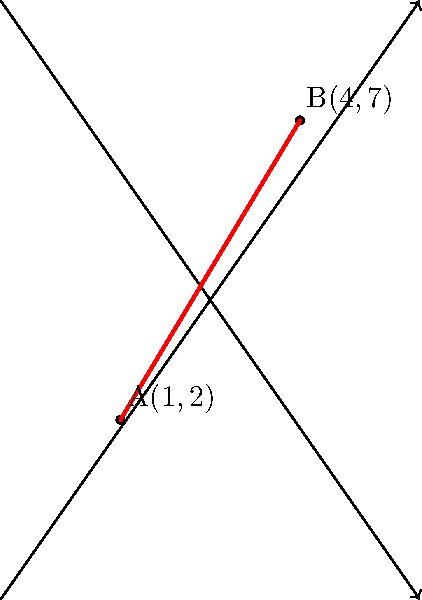In Frank Miller's iconic "Sin City" series, the stark contrasts and angular architecture often create striking linear compositions. Consider two points on such a line: A(1,2) and B(4,7). Determine the equation of the line passing through these points, expressing it in slope-intercept form $(y = mx + b)$. How does this line's angle reflect the sharp, dramatic style typical of Miller's cityscapes? To find the equation of the line passing through points A(1,2) and B(4,7), we'll follow these steps:

1) Calculate the slope (m) using the slope formula:
   $$m = \frac{y_2 - y_1}{x_2 - x_1} = \frac{7 - 2}{4 - 1} = \frac{5}{3}$$

2) Use the point-slope form of a line $(y - y_1 = m(x - x_1))$ with point A(1,2):
   $$y - 2 = \frac{5}{3}(x - 1)$$

3) Expand the equation:
   $$y - 2 = \frac{5}{3}x - \frac{5}{3}$$

4) Add 2 to both sides to isolate y:
   $$y = \frac{5}{3}x - \frac{5}{3} + 2$$

5) Simplify:
   $$y = \frac{5}{3}x + \frac{1}{3}$$

This equation represents a line with a steep positive slope (5/3 ≈ 1.67), which aligns with the sharp, dramatic angles often seen in Miller's cityscapes. The y-intercept (1/3) indicates where the line crosses the y-axis, potentially representing the base of a building or street level in a Miller-esque urban setting.
Answer: $y = \frac{5}{3}x + \frac{1}{3}$ 